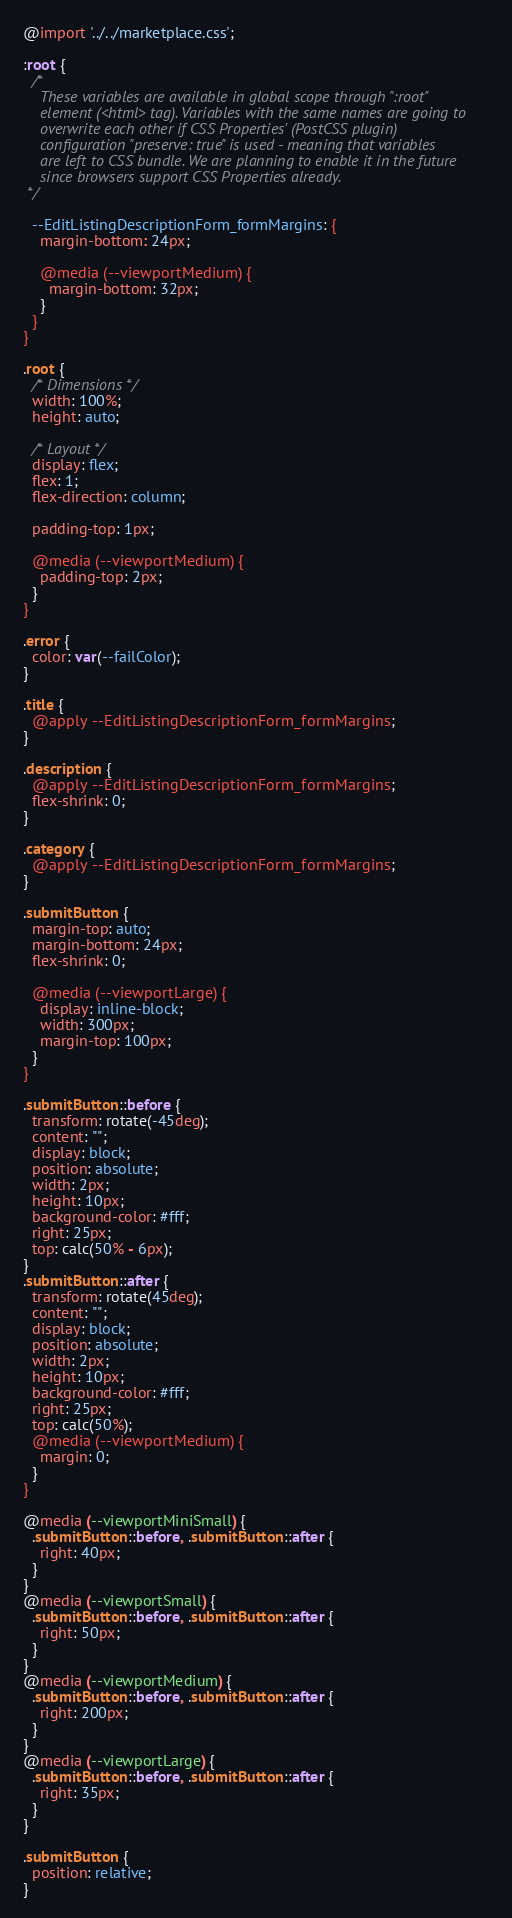<code> <loc_0><loc_0><loc_500><loc_500><_CSS_>@import '../../marketplace.css';

:root {
  /*
    These variables are available in global scope through ":root"
    element (<html> tag). Variables with the same names are going to
    overwrite each other if CSS Properties' (PostCSS plugin)
    configuration "preserve: true" is used - meaning that variables
    are left to CSS bundle. We are planning to enable it in the future
    since browsers support CSS Properties already.
 */

  --EditListingDescriptionForm_formMargins: {
    margin-bottom: 24px;

    @media (--viewportMedium) {
      margin-bottom: 32px;
    }
  }
}

.root {
  /* Dimensions */
  width: 100%;
  height: auto;

  /* Layout */
  display: flex;
  flex: 1;
  flex-direction: column;

  padding-top: 1px;

  @media (--viewportMedium) {
    padding-top: 2px;
  }
}

.error {
  color: var(--failColor);
}

.title {
  @apply --EditListingDescriptionForm_formMargins;
}

.description {
  @apply --EditListingDescriptionForm_formMargins;
  flex-shrink: 0;
}

.category {
  @apply --EditListingDescriptionForm_formMargins;
}

.submitButton {
  margin-top: auto;
  margin-bottom: 24px;
  flex-shrink: 0;

  @media (--viewportLarge) {
    display: inline-block;
    width: 300px;
    margin-top: 100px;
  }
}

.submitButton::before {
  transform: rotate(-45deg);
  content: "";
  display: block;
  position: absolute;
  width: 2px;
  height: 10px;
  background-color: #fff;
  right: 25px;
  top: calc(50% - 6px);
}
.submitButton::after {
  transform: rotate(45deg);
  content: "";
  display: block;
  position: absolute;
  width: 2px;
  height: 10px;
  background-color: #fff;
  right: 25px;
  top: calc(50%);
  @media (--viewportMedium) {
    margin: 0;
  }
}

@media (--viewportMiniSmall) {
  .submitButton::before, .submitButton::after {
    right: 40px;
  }
}
@media (--viewportSmall) {
  .submitButton::before, .submitButton::after {
    right: 50px;
  }
}
@media (--viewportMedium) {
  .submitButton::before, .submitButton::after {
    right: 200px;
  }
}
@media (--viewportLarge) {
  .submitButton::before, .submitButton::after {
    right: 35px;
  }
}

.submitButton {
  position: relative;
}
</code> 